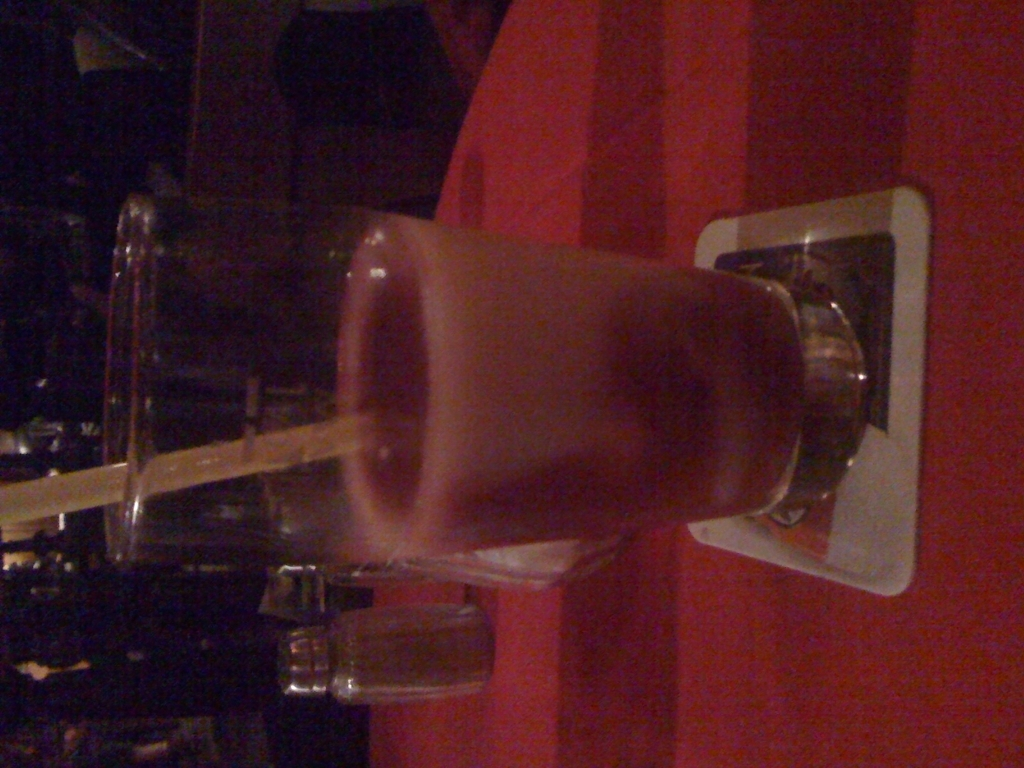Is this image intended to be artistic, given its unusual angle? The rotated angle of the image could be an artistic choice, aiming to present a familiar subject in an unfamiliar way to catch the viewer's interest. However, if the intent was not artistic, correcting the orientation would likely make the image more appealing for conventional purposes. How would you fix the orientation to improve the image? To correct the orientation of the image, it should be rotated 90 degrees to the right. This adjustment would allow the viewer to see the drink upright, which is how it would normally be presented and consumed, making the image more relatable and accessible. 